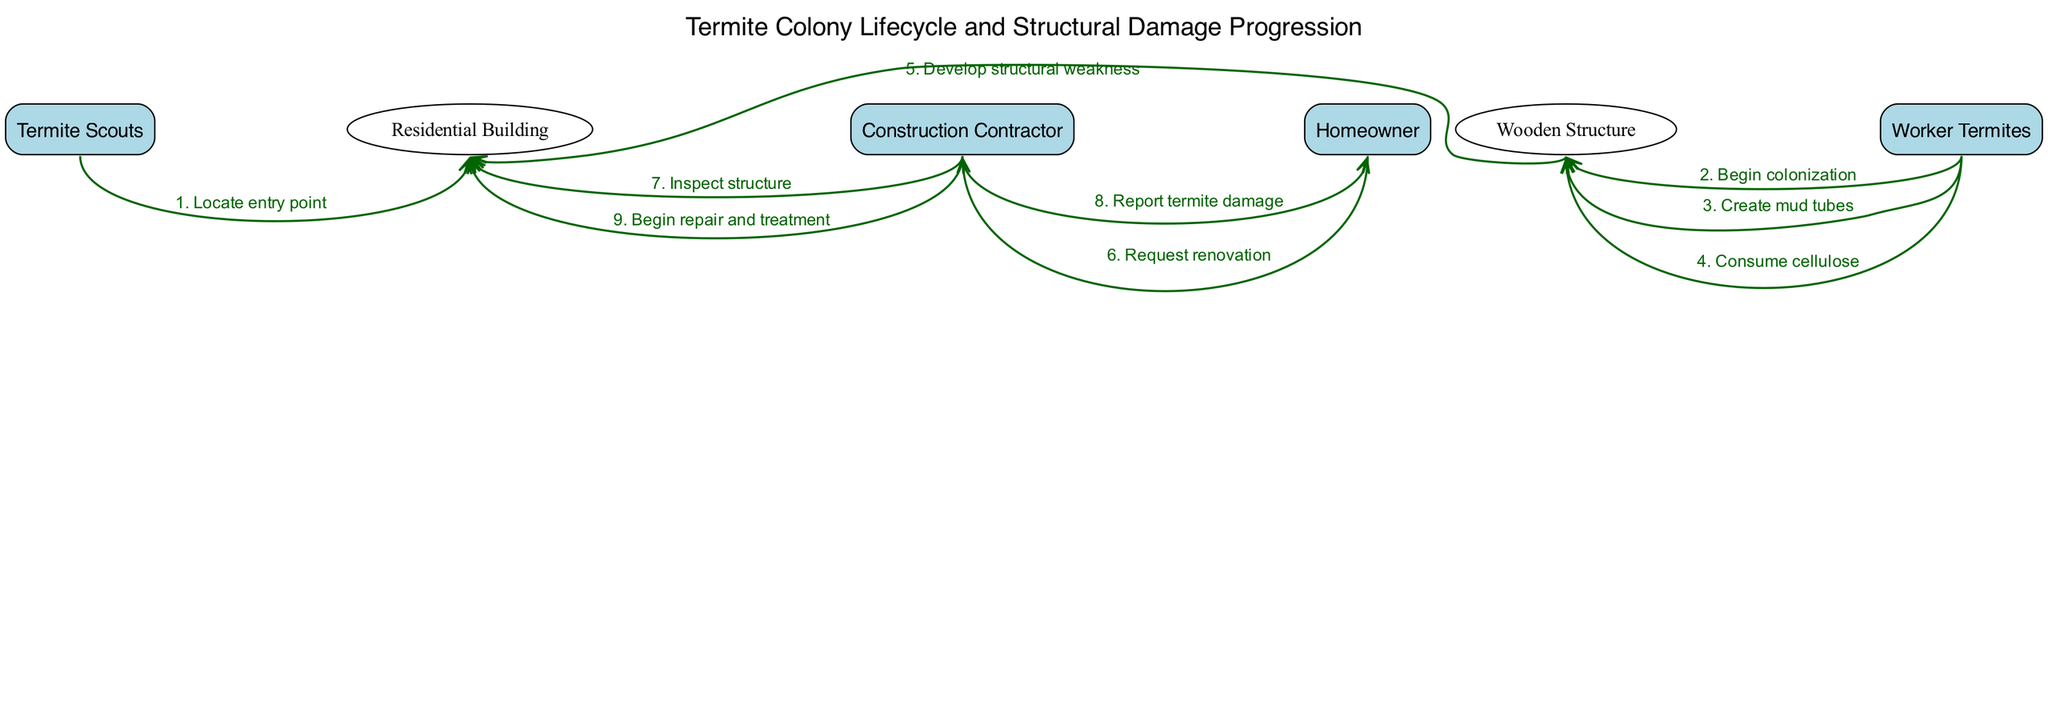What are the actors involved in the diagram? The diagram includes four actors: Termite Scouts, Worker Termites, Construction Contractor, and Homeowner.
Answer: Termite Scouts, Worker Termites, Construction Contractor, Homeowner What is the first action taken in the sequence? The first action in the sequence is taken by the Termite Scouts when they locate an entry point to the residential building.
Answer: Locate entry point How many actions are performed by Worker Termites? There are three actions performed by Worker Termites: begin colonization, create mud tubes, and consume cellulose.
Answer: Three What does the Construction Contractor do after inspecting the structure? After inspecting the structure, the Construction Contractor reports the termite damage to the Homeowner.
Answer: Report termite damage What is the final action in the sequence? The final action in the sequence is the Construction Contractor beginning the repair and treatment of the residential building.
Answer: Begin repair and treatment How does the structural weakness develop in the residential building? The structural weakness develops after Worker Termites consume cellulose from the Wooden Structure, leading to deterioration.
Answer: Consume cellulose What is the relationship between the Homeowner and the Construction Contractor in the diagram? The Homeowner requests renovation from the Construction Contractor, indicating a request for assistance regarding termite damage.
Answer: Request renovation What role do Termite Scouts play in the lifecycle depicted? The role of Termite Scouts is to locate the entry point into the residential building, initiating the infestation process.
Answer: Locate entry point 